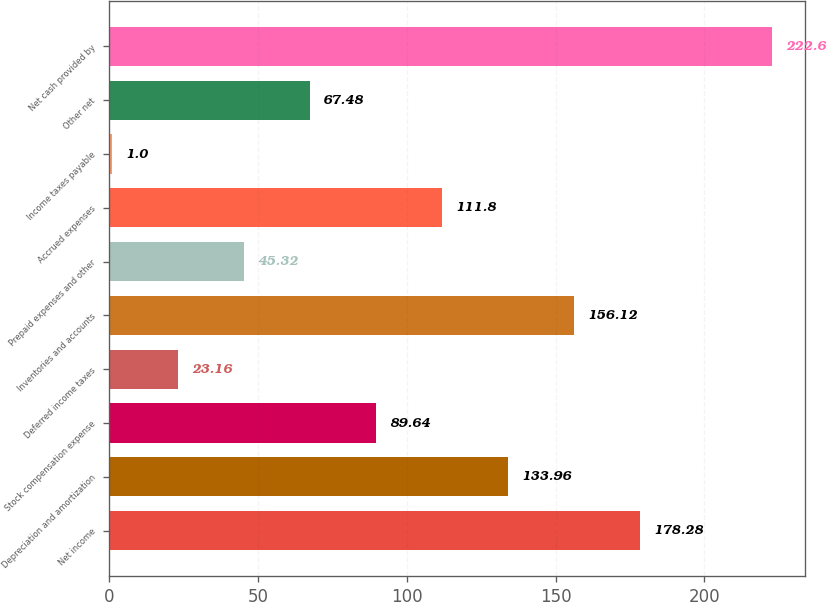Convert chart. <chart><loc_0><loc_0><loc_500><loc_500><bar_chart><fcel>Net income<fcel>Depreciation and amortization<fcel>Stock compensation expense<fcel>Deferred income taxes<fcel>Inventories and accounts<fcel>Prepaid expenses and other<fcel>Accrued expenses<fcel>Income taxes payable<fcel>Other net<fcel>Net cash provided by<nl><fcel>178.28<fcel>133.96<fcel>89.64<fcel>23.16<fcel>156.12<fcel>45.32<fcel>111.8<fcel>1<fcel>67.48<fcel>222.6<nl></chart> 